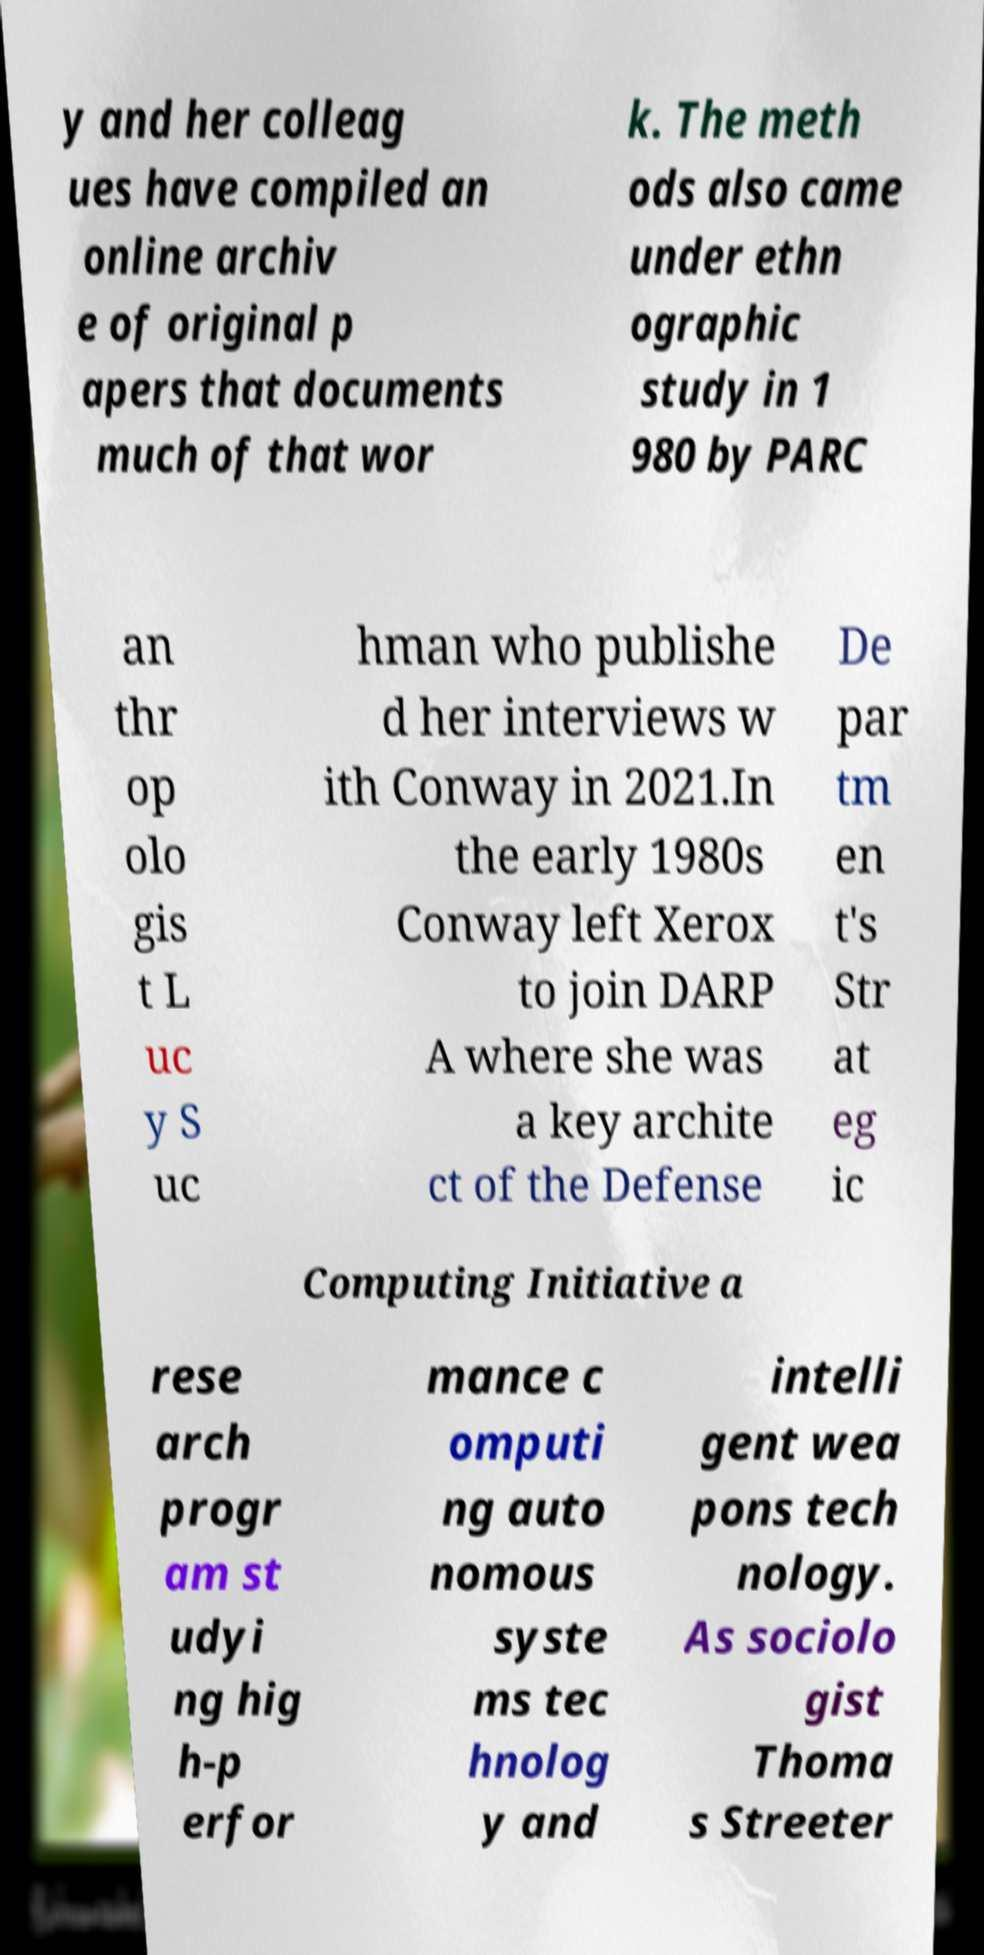For documentation purposes, I need the text within this image transcribed. Could you provide that? y and her colleag ues have compiled an online archiv e of original p apers that documents much of that wor k. The meth ods also came under ethn ographic study in 1 980 by PARC an thr op olo gis t L uc y S uc hman who publishe d her interviews w ith Conway in 2021.In the early 1980s Conway left Xerox to join DARP A where she was a key archite ct of the Defense De par tm en t's Str at eg ic Computing Initiative a rese arch progr am st udyi ng hig h-p erfor mance c omputi ng auto nomous syste ms tec hnolog y and intelli gent wea pons tech nology. As sociolo gist Thoma s Streeter 